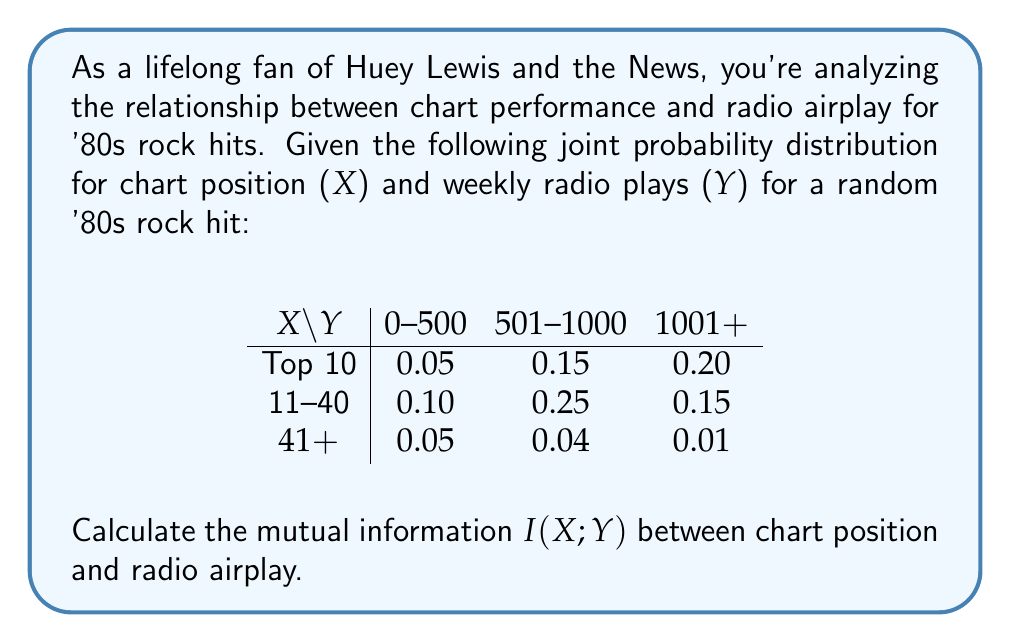Solve this math problem. To calculate the mutual information $I(X;Y)$, we'll follow these steps:

1) First, calculate the marginal probabilities $P(X)$ and $P(Y)$:

   $P(X = \text{Top 10}) = 0.05 + 0.15 + 0.20 = 0.40$
   $P(X = \text{11-40}) = 0.10 + 0.25 + 0.15 = 0.50$
   $P(X = 41+) = 0.05 + 0.04 + 0.01 = 0.10$

   $P(Y = 0-500) = 0.05 + 0.10 + 0.05 = 0.20$
   $P(Y = 501-1000) = 0.15 + 0.25 + 0.04 = 0.44$
   $P(Y = 1001+) = 0.20 + 0.15 + 0.01 = 0.36$

2) The mutual information is given by:

   $$I(X;Y) = \sum_{x \in X} \sum_{y \in Y} P(x,y) \log_2 \frac{P(x,y)}{P(x)P(y)}$$

3) Let's calculate each term:

   $0.05 \log_2 \frac{0.05}{0.40 \cdot 0.20} = 0.05 \log_2 0.625 = -0.0301$
   $0.15 \log_2 \frac{0.15}{0.40 \cdot 0.44} = 0.15 \log_2 0.852 = -0.0330$
   $0.20 \log_2 \frac{0.20}{0.40 \cdot 0.36} = 0.20 \log_2 1.389 = 0.0949$
   $0.10 \log_2 \frac{0.10}{0.50 \cdot 0.20} = 0.10 \log_2 1.000 = 0.0000$
   $0.25 \log_2 \frac{0.25}{0.50 \cdot 0.44} = 0.25 \log_2 1.136 = 0.0395$
   $0.15 \log_2 \frac{0.15}{0.50 \cdot 0.36} = 0.15 \log_2 0.833 = -0.0376$
   $0.05 \log_2 \frac{0.05}{0.10 \cdot 0.20} = 0.05 \log_2 2.500 = 0.0651$
   $0.04 \log_2 \frac{0.04}{0.10 \cdot 0.44} = 0.04 \log_2 0.909 = -0.0040$
   $0.01 \log_2 \frac{0.01}{0.10 \cdot 0.36} = 0.01 \log_2 0.278 = -0.0186$

4) Sum all these terms:

   $I(X;Y) = -0.0301 - 0.0330 + 0.0949 + 0.0000 + 0.0395 - 0.0376 + 0.0651 - 0.0040 - 0.0186 = 0.0762$

Therefore, the mutual information $I(X;Y)$ is approximately 0.0762 bits.
Answer: $0.0762$ bits 